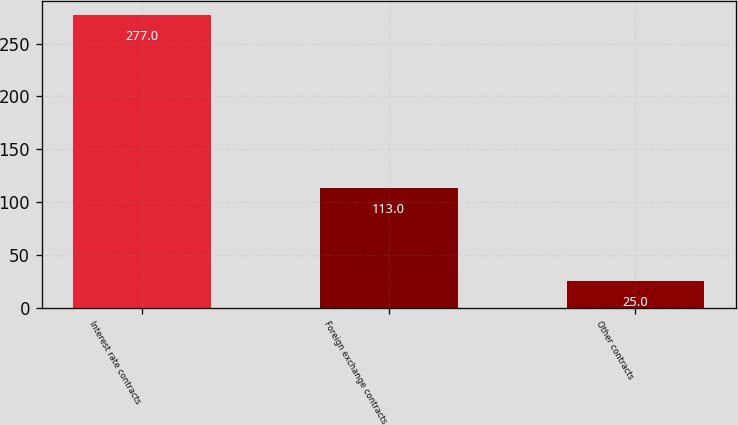Convert chart. <chart><loc_0><loc_0><loc_500><loc_500><bar_chart><fcel>Interest rate contracts<fcel>Foreign exchange contracts<fcel>Other contracts<nl><fcel>277<fcel>113<fcel>25<nl></chart> 